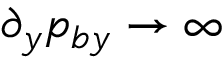Convert formula to latex. <formula><loc_0><loc_0><loc_500><loc_500>\partial _ { y } p _ { b y } \rightarrow \infty</formula> 